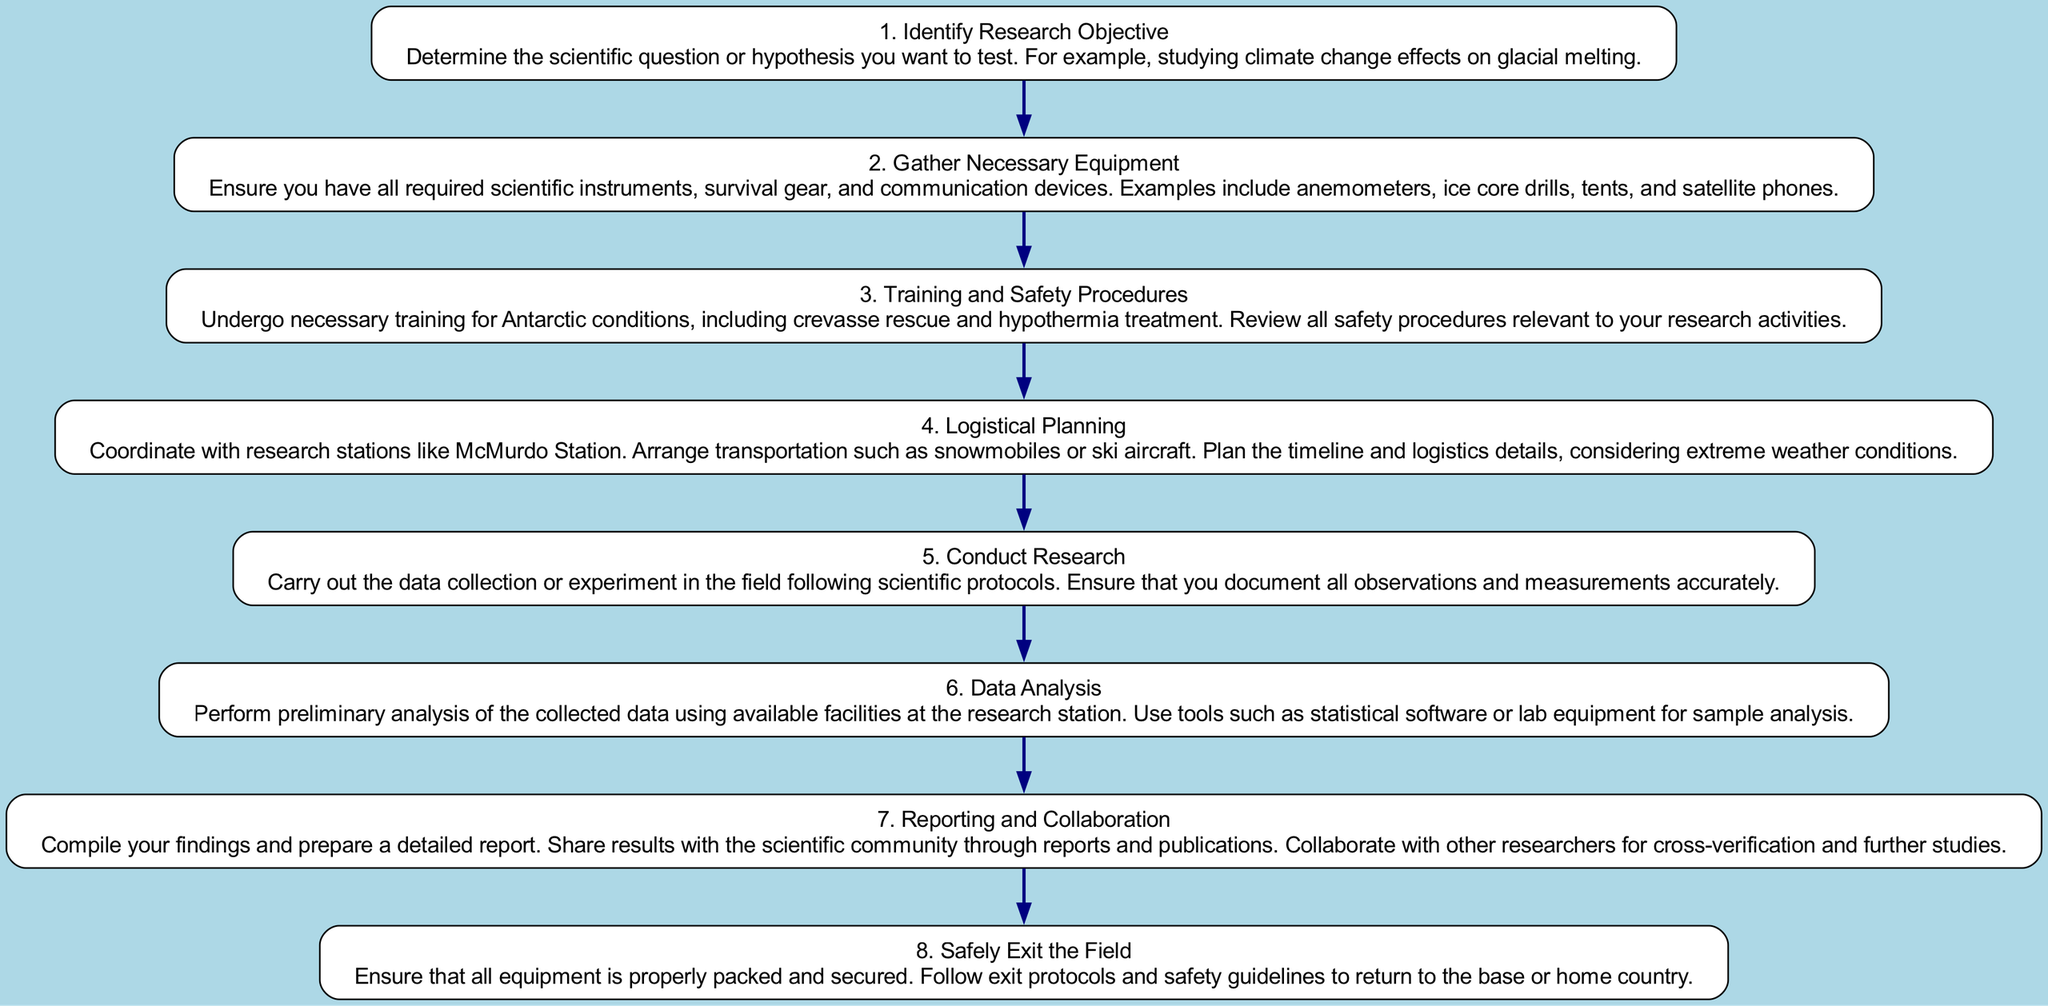What is the first step in the flow chart? The first step in the flow chart is clearly labeled and states "Identify Research Objective". It is depicted as the first node and serves as the starting point of the research process.
Answer: Identify Research Objective How many steps are in the flow chart? By counting each step from the beginning to the end, we identify that there are a total of eight distinct steps represented in the flow chart.
Answer: 8 What follows after "Gather Necessary Equipment"? In the flow chart, "Training and Safety Procedures" directly follows "Gather Necessary Equipment" as indicated by the connecting edge between the two nodes.
Answer: Training and Safety Procedures What does the last step of the flow chart entail? The last step of the flow chart is "Safely Exit the Field", which includes ensuring all equipment is packed and following exit protocols. It concludes the entire research process.
Answer: Safely Exit the Field What is required before "Conduct Research"? Before "Conduct Research", the flow chart indicates that "Logistical Planning" is necessary, showing a sequential relationship between these two steps in the research process.
Answer: Logistical Planning What two steps are connected directly before "Data Analysis"? The steps immediately preceding "Data Analysis" are "Conduct Research" and "Reporting and Collaboration", creating a relationship where data collection leads into analysis before reporting findings.
Answer: Conduct Research and Reporting and Collaboration What must be done during "Reporting and Collaboration"? During "Reporting and Collaboration", the findings need to be compiled and prepared for sharing with the scientific community, as direct instructions from that step emphasize documentation and collaboration.
Answer: Compile findings and prepare a report What type of training is crucial in step three? The crucial type of training required in step three specifically mentions training for "Antarctic conditions", which includes safety procedures necessary for survival in such environments.
Answer: Antarctic conditions training 